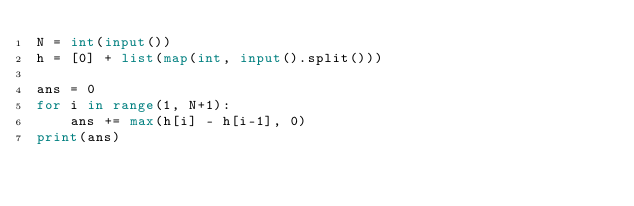Convert code to text. <code><loc_0><loc_0><loc_500><loc_500><_Python_>N = int(input())
h = [0] + list(map(int, input().split()))

ans = 0
for i in range(1, N+1):
    ans += max(h[i] - h[i-1], 0)
print(ans)</code> 